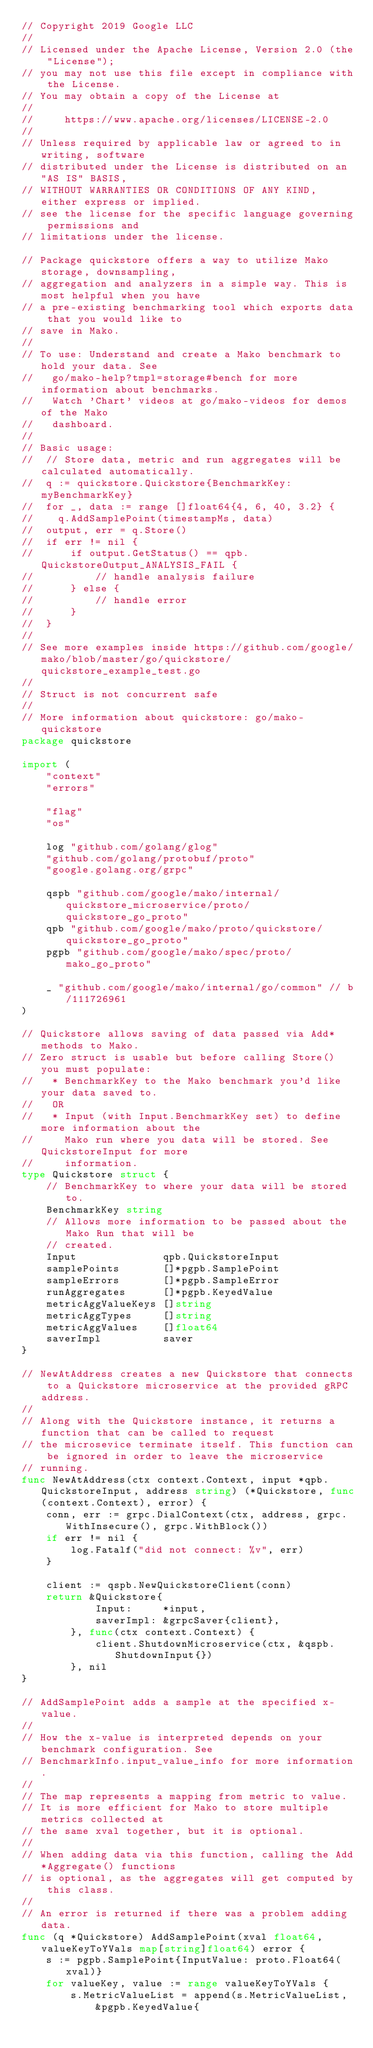<code> <loc_0><loc_0><loc_500><loc_500><_Go_>// Copyright 2019 Google LLC
//
// Licensed under the Apache License, Version 2.0 (the "License");
// you may not use this file except in compliance with the License.
// You may obtain a copy of the License at
//
//     https://www.apache.org/licenses/LICENSE-2.0
//
// Unless required by applicable law or agreed to in writing, software
// distributed under the License is distributed on an "AS IS" BASIS,
// WITHOUT WARRANTIES OR CONDITIONS OF ANY KIND, either express or implied.
// see the license for the specific language governing permissions and
// limitations under the license.

// Package quickstore offers a way to utilize Mako storage, downsampling,
// aggregation and analyzers in a simple way. This is most helpful when you have
// a pre-existing benchmarking tool which exports data that you would like to
// save in Mako.
//
// To use: Understand and create a Mako benchmark to hold your data. See
//   go/mako-help?tmpl=storage#bench for more information about benchmarks.
//   Watch 'Chart' videos at go/mako-videos for demos of the Mako
//   dashboard.
//
// Basic usage:
//  // Store data, metric and run aggregates will be calculated automatically.
//	q := quickstore.Quickstore{BenchmarkKey: myBenchmarkKey}
//  for _, data := range []float64{4, 6, 40, 3.2} {
//    q.AddSamplePoint(timestampMs, data)
//  output, err = q.Store()
//  if err != nil {
//		if output.GetStatus() == qpb.QuickstoreOutput_ANALYSIS_FAIL {
//			// handle analysis failure
//		} else {
//			// handle error
//		}
//  }
//
// See more examples inside https://github.com/google/mako/blob/master/go/quickstore/quickstore_example_test.go
//
// Struct is not concurrent safe
//
// More information about quickstore: go/mako-quickstore
package quickstore

import (
	"context"
	"errors"

	"flag"
	"os"

	log "github.com/golang/glog"
	"github.com/golang/protobuf/proto"
	"google.golang.org/grpc"

	qspb "github.com/google/mako/internal/quickstore_microservice/proto/quickstore_go_proto"
	qpb "github.com/google/mako/proto/quickstore/quickstore_go_proto"
	pgpb "github.com/google/mako/spec/proto/mako_go_proto"

	_ "github.com/google/mako/internal/go/common" // b/111726961
)

// Quickstore allows saving of data passed via Add* methods to Mako.
// Zero struct is usable but before calling Store() you must populate:
//   * BenchmarkKey to the Mako benchmark you'd like your data saved to.
//   OR
//   * Input (with Input.BenchmarkKey set) to define more information about the
//     Mako run where you data will be stored. See QuickstoreInput for more
//     information.
type Quickstore struct {
	// BenchmarkKey to where your data will be stored to.
	BenchmarkKey string
	// Allows more information to be passed about the Mako Run that will be
	// created.
	Input              qpb.QuickstoreInput
	samplePoints       []*pgpb.SamplePoint
	sampleErrors       []*pgpb.SampleError
	runAggregates      []*pgpb.KeyedValue
	metricAggValueKeys []string
	metricAggTypes     []string
	metricAggValues    []float64
	saverImpl          saver
}

// NewAtAddress creates a new Quickstore that connects to a Quickstore microservice at the provided gRPC address.
//
// Along with the Quickstore instance, it returns a function that can be called to request
// the microsevice terminate itself. This function can be ignored in order to leave the microservice
// running.
func NewAtAddress(ctx context.Context, input *qpb.QuickstoreInput, address string) (*Quickstore, func(context.Context), error) {
	conn, err := grpc.DialContext(ctx, address, grpc.WithInsecure(), grpc.WithBlock())
	if err != nil {
		log.Fatalf("did not connect: %v", err)
	}

	client := qspb.NewQuickstoreClient(conn)
	return &Quickstore{
			Input:     *input,
			saverImpl: &grpcSaver{client},
		}, func(ctx context.Context) {
			client.ShutdownMicroservice(ctx, &qspb.ShutdownInput{})
		}, nil
}

// AddSamplePoint adds a sample at the specified x-value.
//
// How the x-value is interpreted depends on your benchmark configuration. See
// BenchmarkInfo.input_value_info for more information.
//
// The map represents a mapping from metric to value.
// It is more efficient for Mako to store multiple metrics collected at
// the same xval together, but it is optional.
//
// When adding data via this function, calling the Add*Aggregate() functions
// is optional, as the aggregates will get computed by this class.
//
// An error is returned if there was a problem adding data.
func (q *Quickstore) AddSamplePoint(xval float64, valueKeyToYVals map[string]float64) error {
	s := pgpb.SamplePoint{InputValue: proto.Float64(xval)}
	for valueKey, value := range valueKeyToYVals {
		s.MetricValueList = append(s.MetricValueList,
			&pgpb.KeyedValue{</code> 